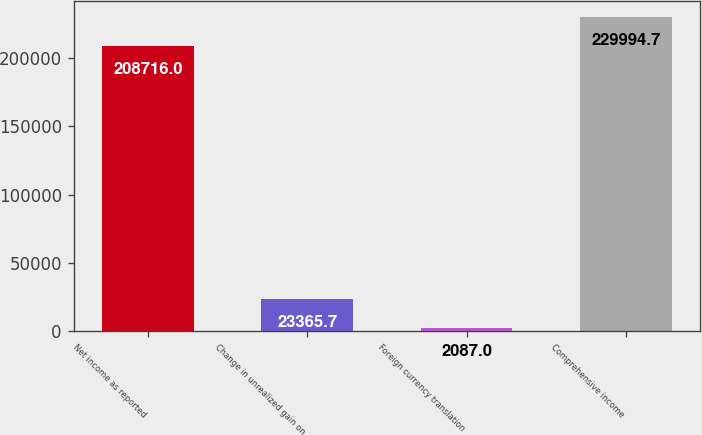<chart> <loc_0><loc_0><loc_500><loc_500><bar_chart><fcel>Net income as reported<fcel>Change in unrealized gain on<fcel>Foreign currency translation<fcel>Comprehensive income<nl><fcel>208716<fcel>23365.7<fcel>2087<fcel>229995<nl></chart> 